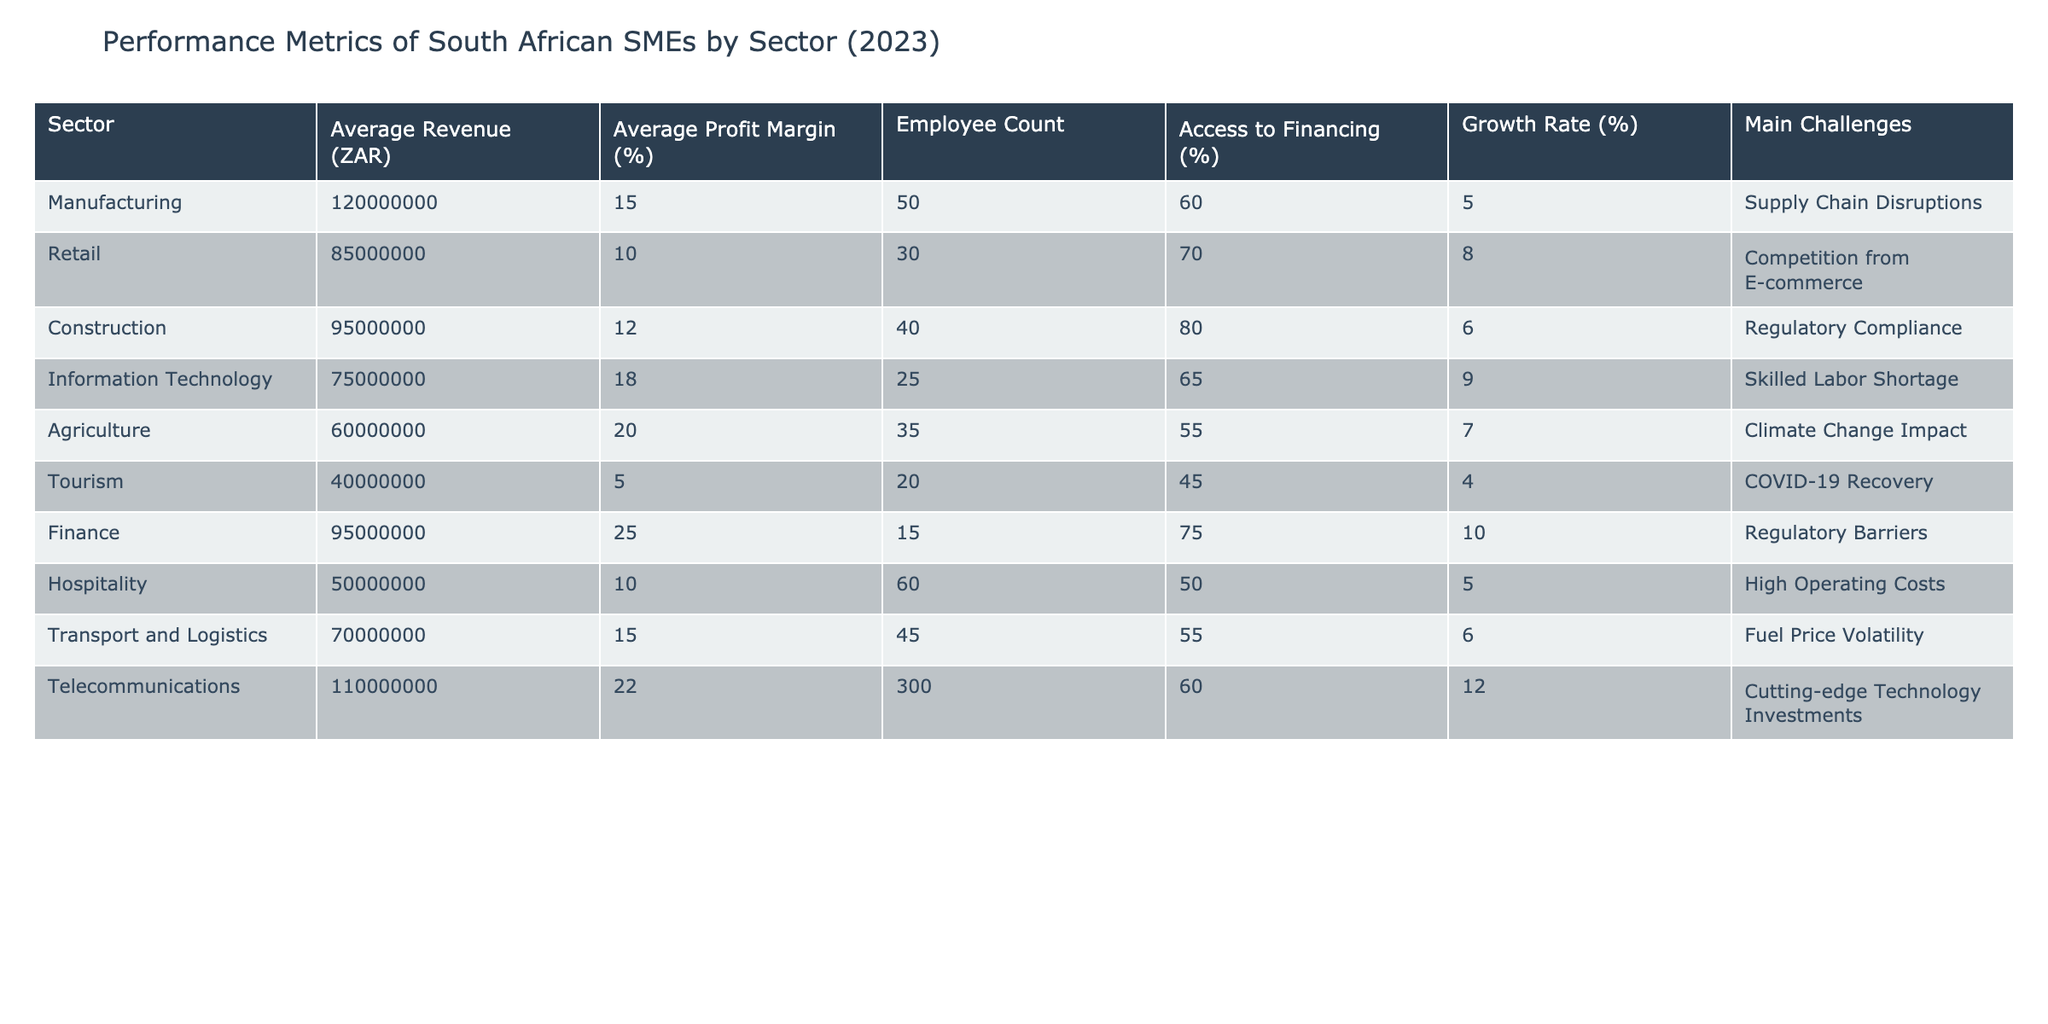What is the average profit margin for the Information Technology sector? The average profit margin for the Information Technology sector is found directly in the table. It is listed as 18%.
Answer: 18% Which sector has the highest average revenue? According to the table, the sector with the highest average revenue is Telecommunications, with an average revenue of ZAR 110,000,000.
Answer: Telecommunications What is the average employee count across all sectors? To find the average employee count, we first sum the employee counts across all sectors: (50 + 30 + 40 + 25 + 35 + 20 + 15 + 60 + 45 + 300) = 650. Then, we divide by the number of sectors, which is 10, resulting in an average of 650/10 = 65.
Answer: 65 Is the agriculture sector's growth rate higher than the average growth rate for all sectors? The growth rates from the table include: 5, 8, 6, 9, 7, 4, 10, 5, 6, 12, which sum to 58. Dividing by 10 gives an average growth rate of 5.8%. The agriculture sector's growth rate is 7%, which is higher than the average.
Answer: Yes What is the difference in average revenue between the Finance and Transport and Logistics sectors? The average revenue for Finance is ZAR 95,000,000 and for Transport and Logistics it is ZAR 70,000,000. To find the difference, we subtract the lower revenue from the higher revenue: 95,000,000 - 70,000,000 = 25,000,000.
Answer: 25,000,000 Which sector faces supply chain disruptions as its main challenge? According to the table, the sector that lists supply chain disruptions as its main challenge is Manufacturing.
Answer: Manufacturing How many sectors have an access to financing percentage above 60%? The sectors with access to financing above 60% are Manufacturing (60%), Retail (70%), Construction (80%), Finance (75%), and Telecommunications (60%). Counting these yields 4 sectors (note that Telecommunications is at exactly 60%).
Answer: 4 What is the total number of employees across the Manufacturing and Retail sectors? From the table, the employee counts in Manufacturing is 50 and in Retail is 30. Summing these gives: 50 + 30 = 80.
Answer: 80 Are there more sectors that report high growth rates (above 8%) than low profit margins (below 10%)? The sectors with a growth rate above 8% are Information Technology (9%), Finance (10%), and Telecommunications (12%). The sectors with a profit margin below 10% are Retail (10%), Tourism (5%), and Hospitality (10%). Thus, we have 3 sectors that have high growth rates and 3 with low profit margins which are equal.
Answer: No 